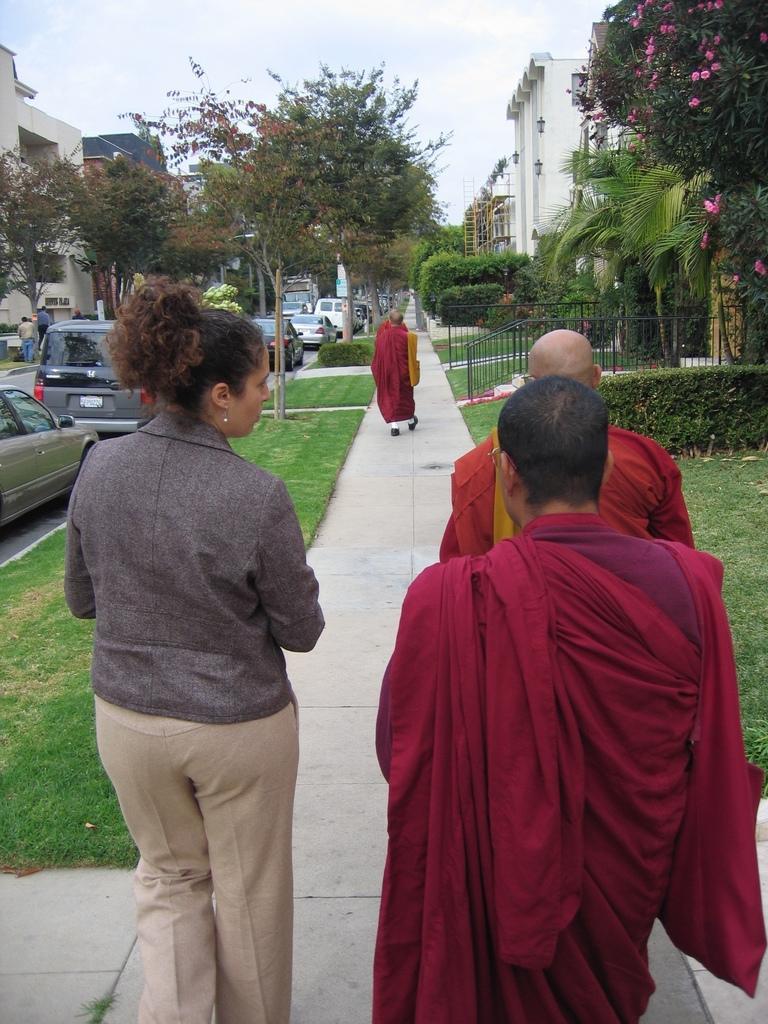Describe this image in one or two sentences. In this picture there are priests on the right side of the image and there is a lady on the left side of the image, there are buildings and trees at the top side of the image and there are cars on the left side of the image. 